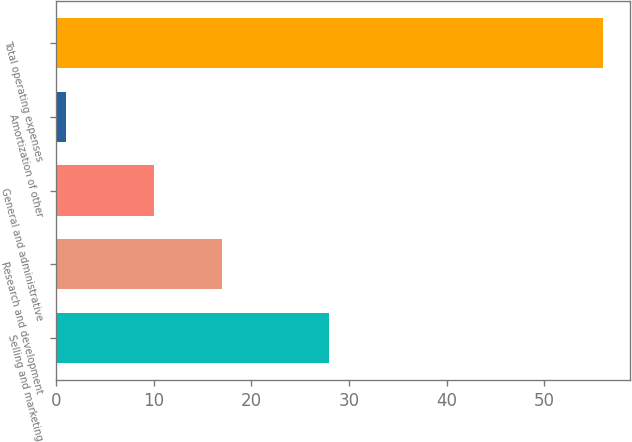Convert chart to OTSL. <chart><loc_0><loc_0><loc_500><loc_500><bar_chart><fcel>Selling and marketing<fcel>Research and development<fcel>General and administrative<fcel>Amortization of other<fcel>Total operating expenses<nl><fcel>28<fcel>17<fcel>10<fcel>1<fcel>56<nl></chart> 